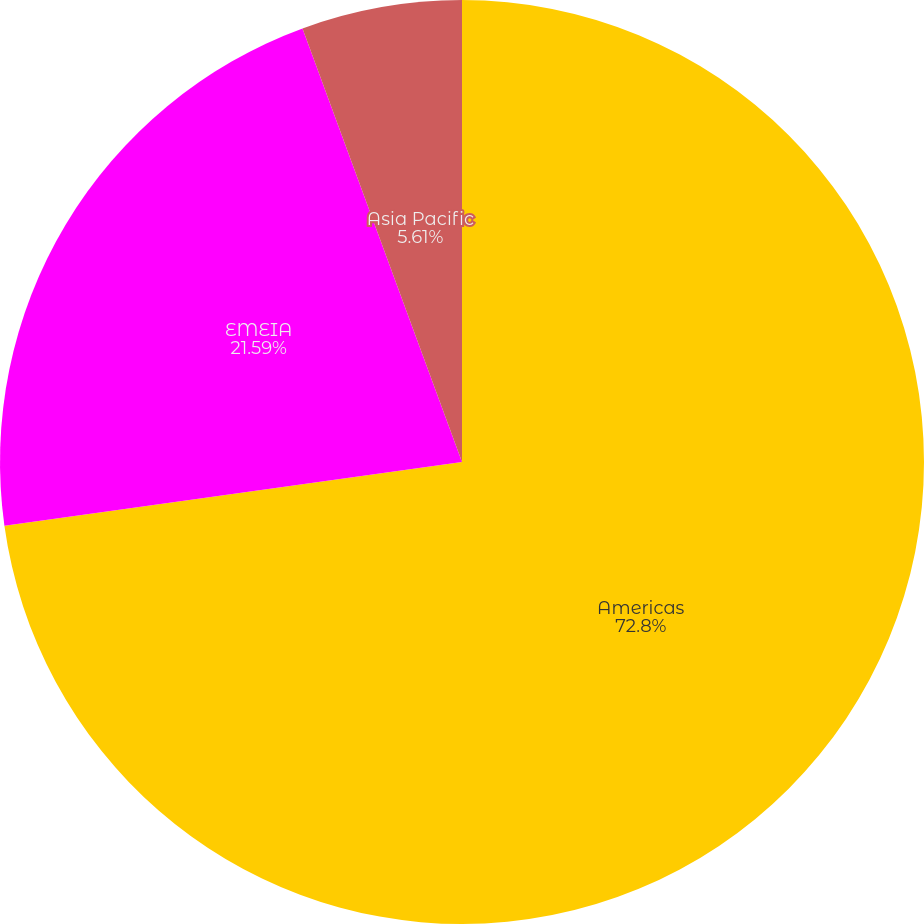<chart> <loc_0><loc_0><loc_500><loc_500><pie_chart><fcel>Americas<fcel>EMEIA<fcel>Asia Pacific<nl><fcel>72.8%<fcel>21.59%<fcel>5.61%<nl></chart> 